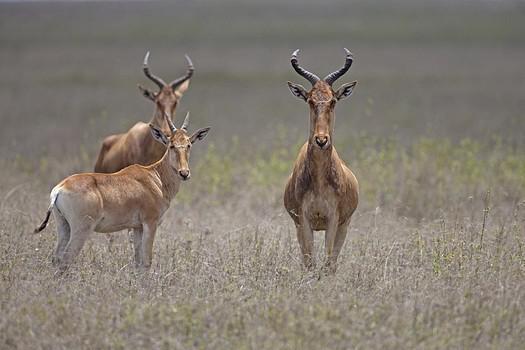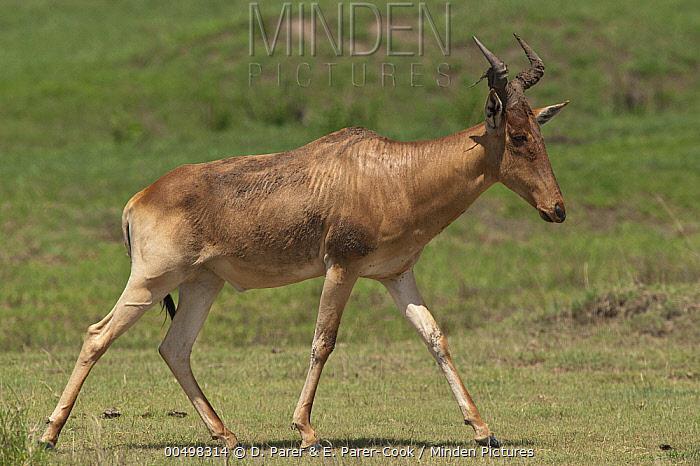The first image is the image on the left, the second image is the image on the right. For the images shown, is this caption "A single horned animal is standing in the grass in the image on the left." true? Answer yes or no. No. The first image is the image on the left, the second image is the image on the right. For the images shown, is this caption "Left image contains one horned animal, standing with its body turned rightward." true? Answer yes or no. No. 